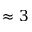Convert formula to latex. <formula><loc_0><loc_0><loc_500><loc_500>\approx 3</formula> 